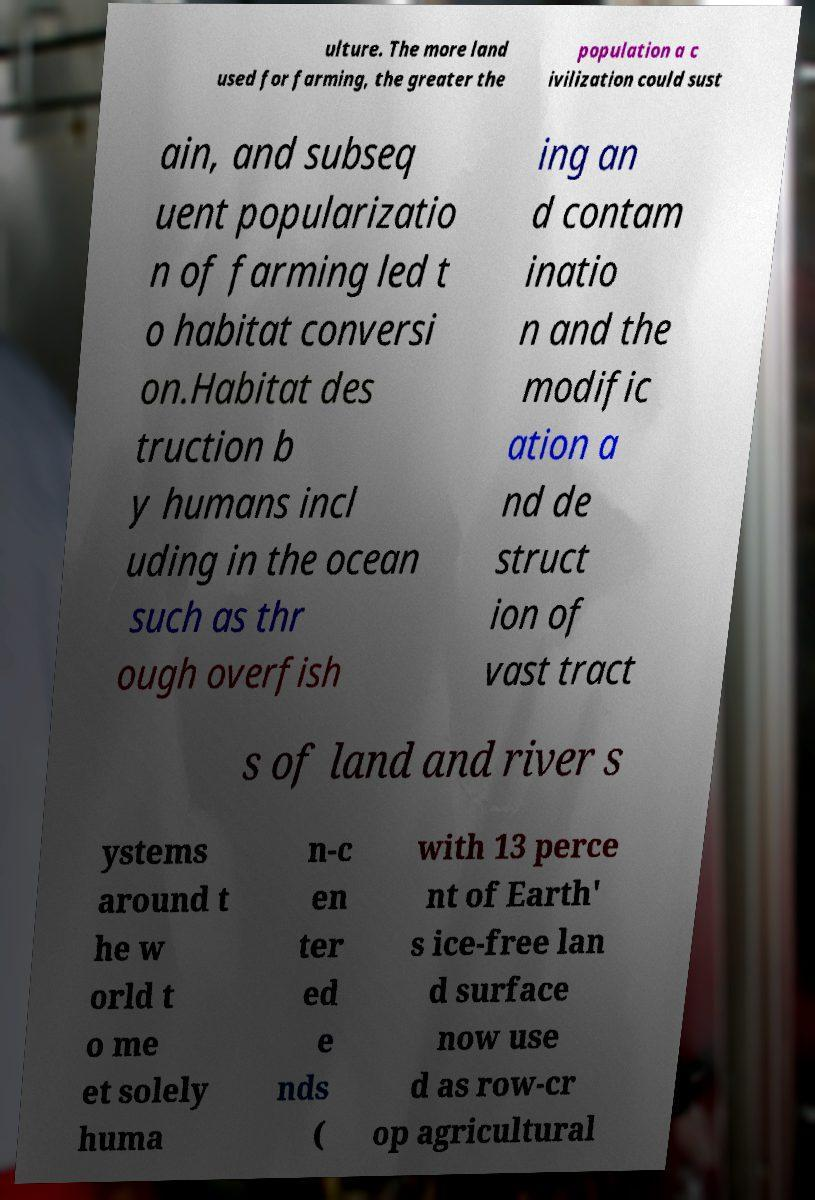I need the written content from this picture converted into text. Can you do that? ulture. The more land used for farming, the greater the population a c ivilization could sust ain, and subseq uent popularizatio n of farming led t o habitat conversi on.Habitat des truction b y humans incl uding in the ocean such as thr ough overfish ing an d contam inatio n and the modific ation a nd de struct ion of vast tract s of land and river s ystems around t he w orld t o me et solely huma n-c en ter ed e nds ( with 13 perce nt of Earth' s ice-free lan d surface now use d as row-cr op agricultural 